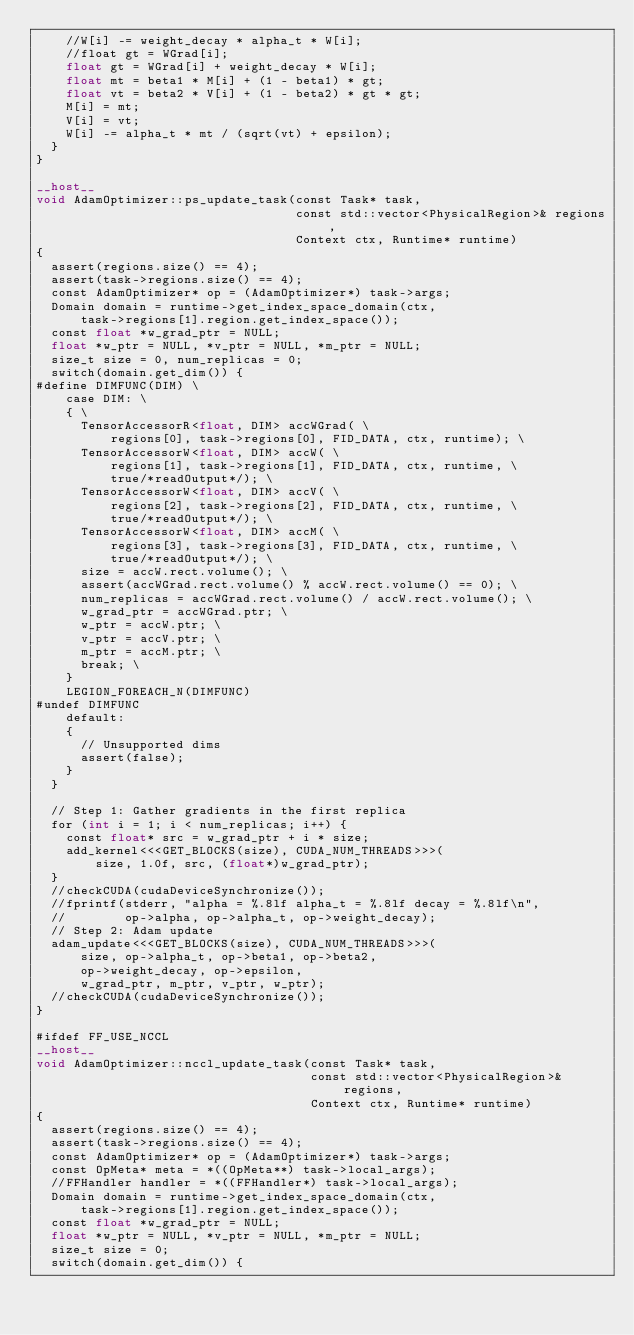Convert code to text. <code><loc_0><loc_0><loc_500><loc_500><_Cuda_>    //W[i] -= weight_decay * alpha_t * W[i];
    //float gt = WGrad[i];
    float gt = WGrad[i] + weight_decay * W[i];
    float mt = beta1 * M[i] + (1 - beta1) * gt;
    float vt = beta2 * V[i] + (1 - beta2) * gt * gt;
    M[i] = mt;
    V[i] = vt;
    W[i] -= alpha_t * mt / (sqrt(vt) + epsilon);
  }
}

__host__
void AdamOptimizer::ps_update_task(const Task* task,
                                   const std::vector<PhysicalRegion>& regions,
                                   Context ctx, Runtime* runtime)
{
  assert(regions.size() == 4);
  assert(task->regions.size() == 4);
  const AdamOptimizer* op = (AdamOptimizer*) task->args;
  Domain domain = runtime->get_index_space_domain(ctx,
      task->regions[1].region.get_index_space());
  const float *w_grad_ptr = NULL;
  float *w_ptr = NULL, *v_ptr = NULL, *m_ptr = NULL;
  size_t size = 0, num_replicas = 0;
  switch(domain.get_dim()) {
#define DIMFUNC(DIM) \
    case DIM: \
    { \
      TensorAccessorR<float, DIM> accWGrad( \
          regions[0], task->regions[0], FID_DATA, ctx, runtime); \
      TensorAccessorW<float, DIM> accW( \
          regions[1], task->regions[1], FID_DATA, ctx, runtime, \
          true/*readOutput*/); \
      TensorAccessorW<float, DIM> accV( \
          regions[2], task->regions[2], FID_DATA, ctx, runtime, \
          true/*readOutput*/); \
      TensorAccessorW<float, DIM> accM( \
          regions[3], task->regions[3], FID_DATA, ctx, runtime, \
          true/*readOutput*/); \
      size = accW.rect.volume(); \
      assert(accWGrad.rect.volume() % accW.rect.volume() == 0); \
      num_replicas = accWGrad.rect.volume() / accW.rect.volume(); \
      w_grad_ptr = accWGrad.ptr; \
      w_ptr = accW.ptr; \
      v_ptr = accV.ptr; \
      m_ptr = accM.ptr; \
      break; \
    }
    LEGION_FOREACH_N(DIMFUNC)
#undef DIMFUNC
    default:
    {
      // Unsupported dims
      assert(false);
    }
  }

  // Step 1: Gather gradients in the first replica
  for (int i = 1; i < num_replicas; i++) {
    const float* src = w_grad_ptr + i * size;
    add_kernel<<<GET_BLOCKS(size), CUDA_NUM_THREADS>>>(
        size, 1.0f, src, (float*)w_grad_ptr);
  }
  //checkCUDA(cudaDeviceSynchronize());
  //fprintf(stderr, "alpha = %.8lf alpha_t = %.8lf decay = %.8lf\n",
  //        op->alpha, op->alpha_t, op->weight_decay);
  // Step 2: Adam update
  adam_update<<<GET_BLOCKS(size), CUDA_NUM_THREADS>>>(
      size, op->alpha_t, op->beta1, op->beta2,
      op->weight_decay, op->epsilon,
      w_grad_ptr, m_ptr, v_ptr, w_ptr);
  //checkCUDA(cudaDeviceSynchronize());
}

#ifdef FF_USE_NCCL
__host__
void AdamOptimizer::nccl_update_task(const Task* task,
                                     const std::vector<PhysicalRegion>& regions,
                                     Context ctx, Runtime* runtime)
{
  assert(regions.size() == 4);
  assert(task->regions.size() == 4);
  const AdamOptimizer* op = (AdamOptimizer*) task->args;
  const OpMeta* meta = *((OpMeta**) task->local_args);
  //FFHandler handler = *((FFHandler*) task->local_args);
  Domain domain = runtime->get_index_space_domain(ctx,
      task->regions[1].region.get_index_space());
  const float *w_grad_ptr = NULL;
  float *w_ptr = NULL, *v_ptr = NULL, *m_ptr = NULL;
  size_t size = 0;
  switch(domain.get_dim()) {</code> 